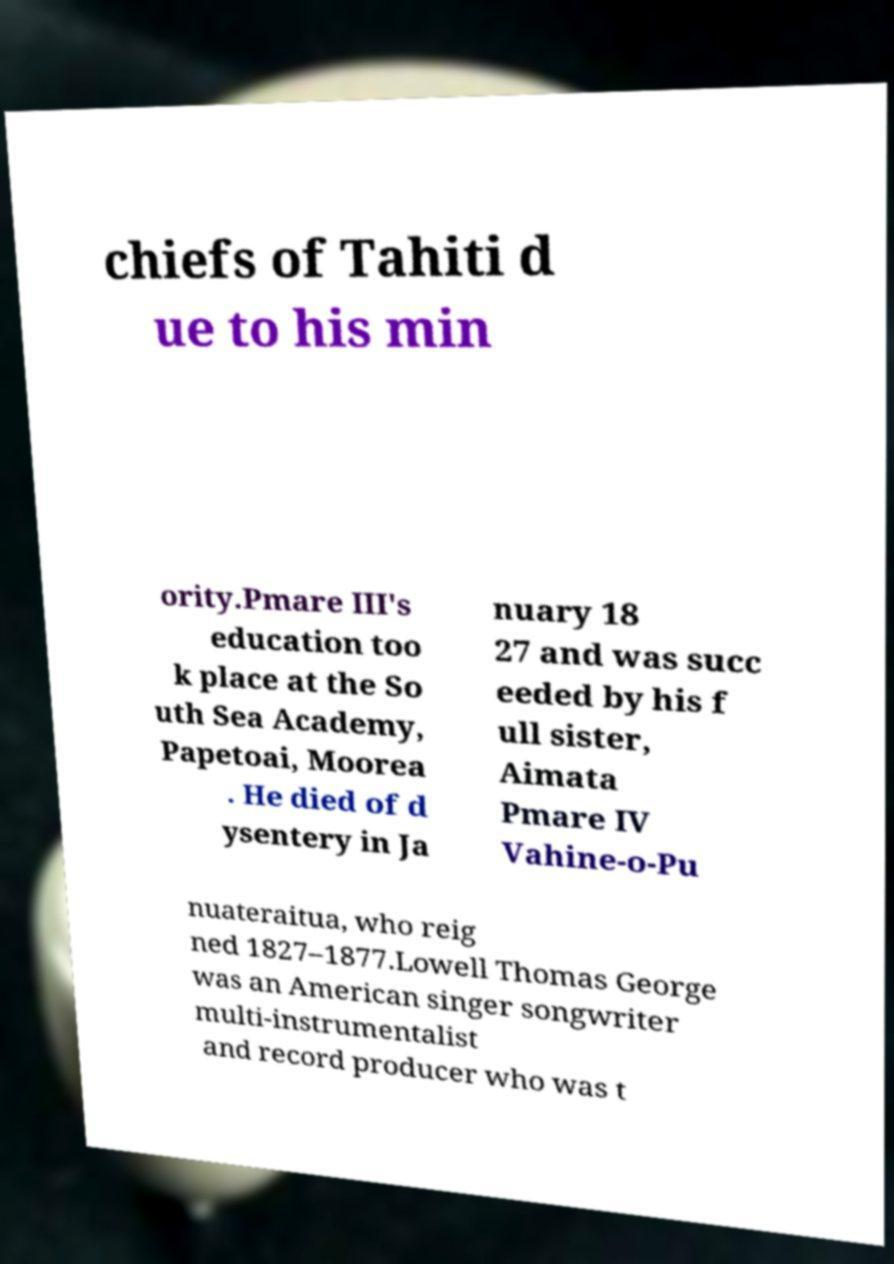Could you assist in decoding the text presented in this image and type it out clearly? chiefs of Tahiti d ue to his min ority.Pmare III's education too k place at the So uth Sea Academy, Papetoai, Moorea . He died of d ysentery in Ja nuary 18 27 and was succ eeded by his f ull sister, Aimata Pmare IV Vahine-o-Pu nuateraitua, who reig ned 1827–1877.Lowell Thomas George was an American singer songwriter multi-instrumentalist and record producer who was t 